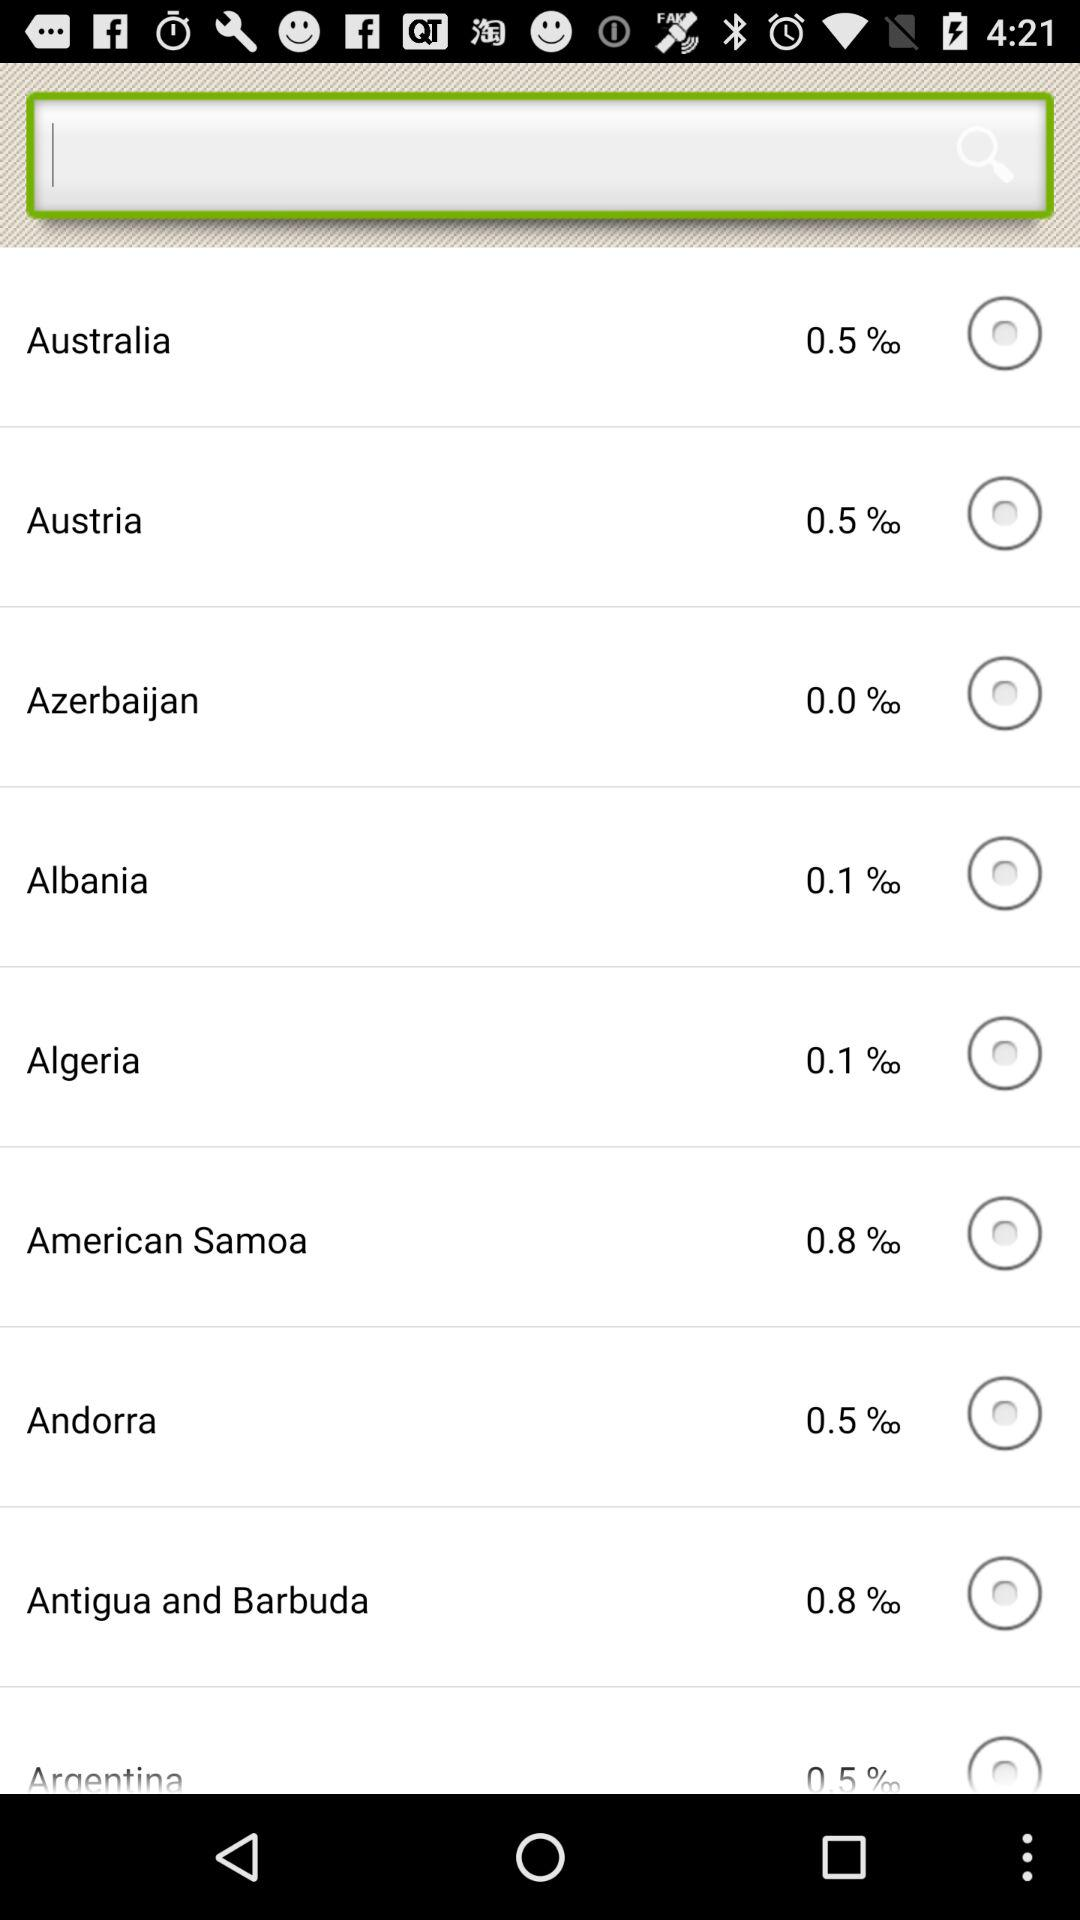How many countries have a COVID-19 infection rate of less than 1%?
Answer the question using a single word or phrase. 9 